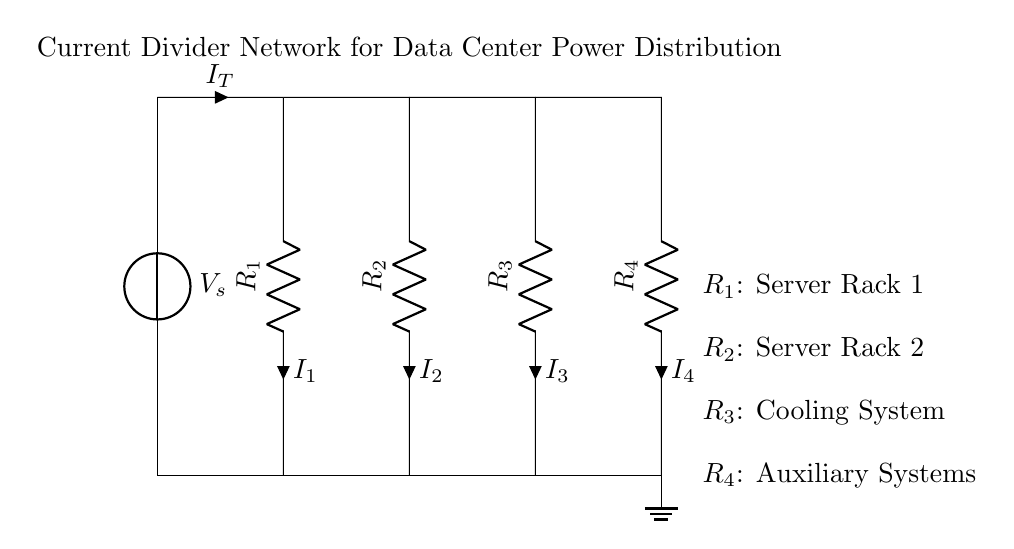What is the total current entering the divider network? The total current is represented by the symbol I_T at the input of the circuit.
Answer: I_T How many resistors are in the current divider network? There are four resistors labeled R_1, R_2, R_3, and R_4 in the circuit diagram.
Answer: 4 Which component corresponds to the auxiliary systems? The auxiliary systems are represented by the resistor R_4 in the circuit.
Answer: R_4 What is the current flowing through the resistor R_2? The current flowing through R_2 is denoted by the symbol I_2 next to the resistor in the diagram.
Answer: I_2 What type of circuit is depicted in the diagram? The circuit is a current divider that distributes current among multiple branches.
Answer: Current divider Explain the relationship between the resistors in terms of current division. In a current divider, the input current I_T splits into different branch currents I_1, I_2, I_3, and I_4 inversely proportional to their resistances. Therefore, a higher resistance results in a smaller branch current.
Answer: Inversely proportional to resistance 